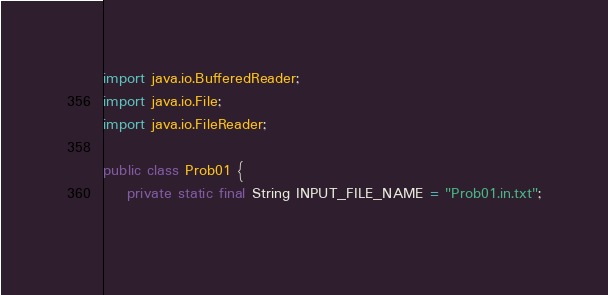<code> <loc_0><loc_0><loc_500><loc_500><_Java_>

import java.io.BufferedReader;
import java.io.File;
import java.io.FileReader;

public class Prob01 {
    private static final String INPUT_FILE_NAME = "Prob01.in.txt";
    </code> 